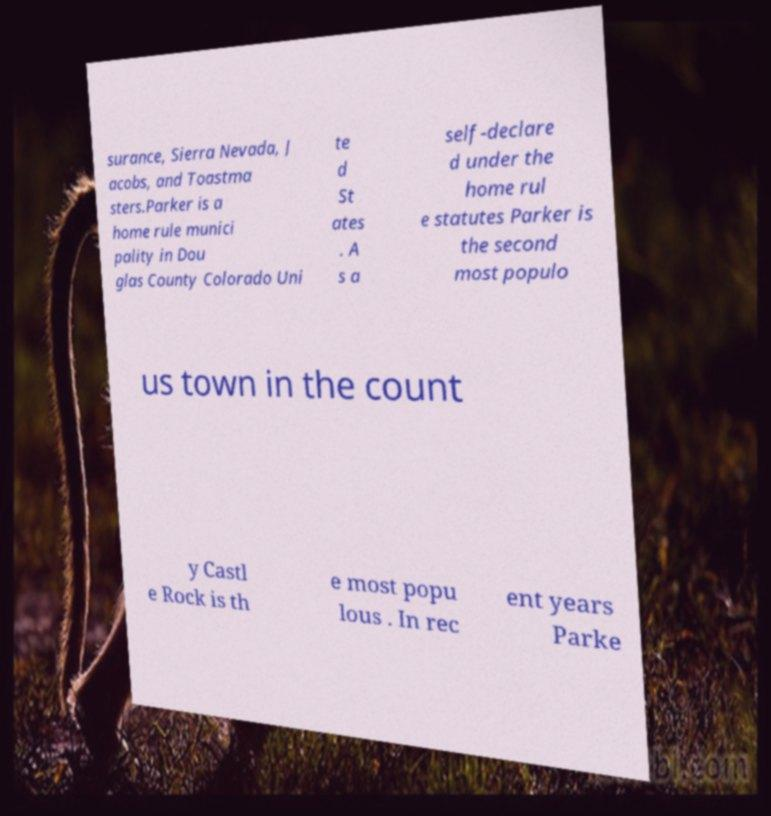I need the written content from this picture converted into text. Can you do that? surance, Sierra Nevada, J acobs, and Toastma sters.Parker is a home rule munici pality in Dou glas County Colorado Uni te d St ates . A s a self-declare d under the home rul e statutes Parker is the second most populo us town in the count y Castl e Rock is th e most popu lous . In rec ent years Parke 